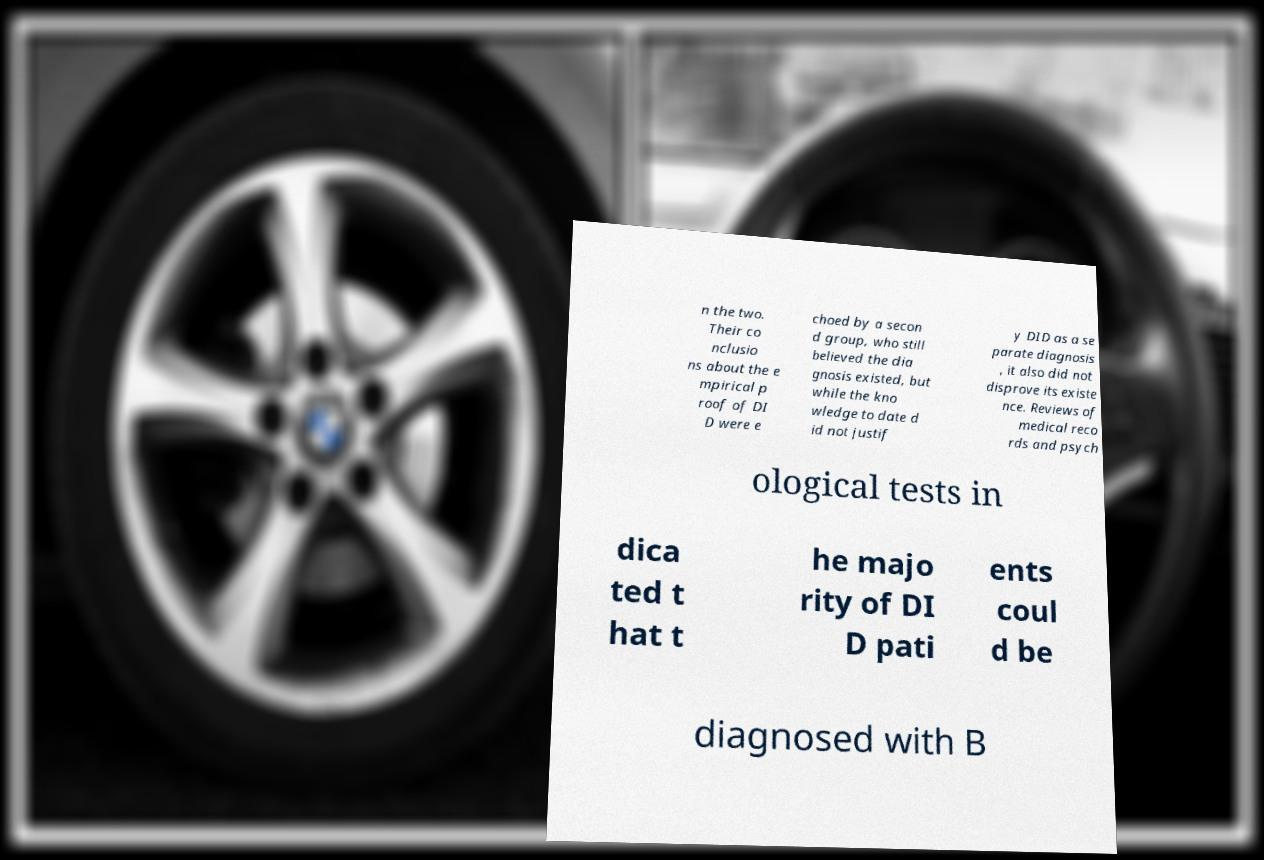There's text embedded in this image that I need extracted. Can you transcribe it verbatim? n the two. Their co nclusio ns about the e mpirical p roof of DI D were e choed by a secon d group, who still believed the dia gnosis existed, but while the kno wledge to date d id not justif y DID as a se parate diagnosis , it also did not disprove its existe nce. Reviews of medical reco rds and psych ological tests in dica ted t hat t he majo rity of DI D pati ents coul d be diagnosed with B 